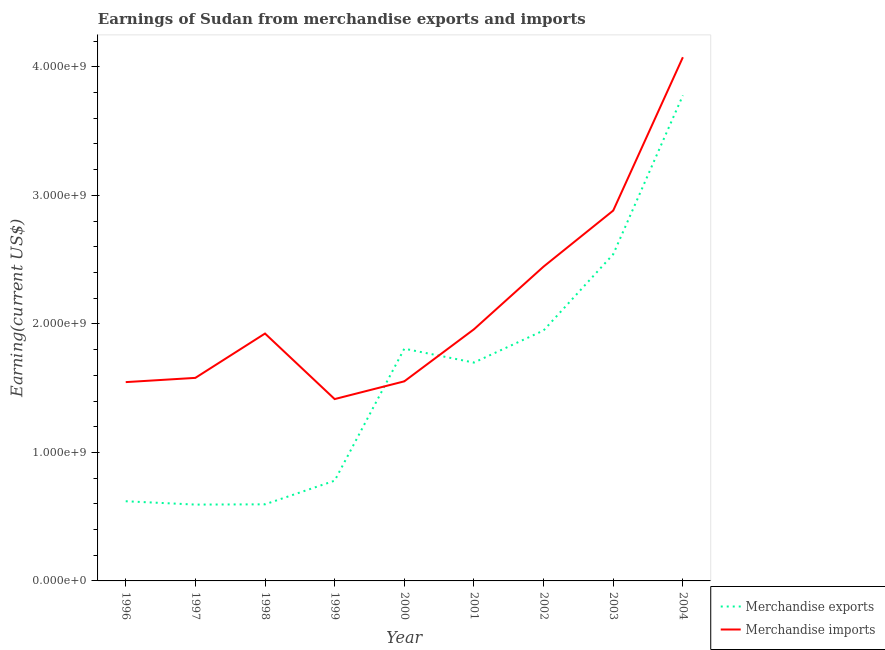How many different coloured lines are there?
Your answer should be compact. 2. Is the number of lines equal to the number of legend labels?
Give a very brief answer. Yes. What is the earnings from merchandise exports in 1998?
Keep it short and to the point. 5.96e+08. Across all years, what is the maximum earnings from merchandise exports?
Provide a succinct answer. 3.78e+09. Across all years, what is the minimum earnings from merchandise imports?
Your response must be concise. 1.42e+09. In which year was the earnings from merchandise imports maximum?
Offer a very short reply. 2004. In which year was the earnings from merchandise imports minimum?
Ensure brevity in your answer.  1999. What is the total earnings from merchandise imports in the graph?
Provide a short and direct response. 1.94e+1. What is the difference between the earnings from merchandise imports in 1998 and that in 2002?
Provide a succinct answer. -5.21e+08. What is the difference between the earnings from merchandise imports in 2002 and the earnings from merchandise exports in 1998?
Keep it short and to the point. 1.85e+09. What is the average earnings from merchandise imports per year?
Your answer should be compact. 2.15e+09. In the year 1997, what is the difference between the earnings from merchandise imports and earnings from merchandise exports?
Provide a short and direct response. 9.86e+08. In how many years, is the earnings from merchandise exports greater than 3400000000 US$?
Make the answer very short. 1. What is the ratio of the earnings from merchandise exports in 1999 to that in 2002?
Provide a short and direct response. 0.4. Is the difference between the earnings from merchandise exports in 2001 and 2003 greater than the difference between the earnings from merchandise imports in 2001 and 2003?
Offer a terse response. Yes. What is the difference between the highest and the second highest earnings from merchandise exports?
Offer a very short reply. 1.24e+09. What is the difference between the highest and the lowest earnings from merchandise exports?
Make the answer very short. 3.18e+09. In how many years, is the earnings from merchandise imports greater than the average earnings from merchandise imports taken over all years?
Offer a terse response. 3. Is the sum of the earnings from merchandise exports in 1997 and 1999 greater than the maximum earnings from merchandise imports across all years?
Ensure brevity in your answer.  No. Does the earnings from merchandise exports monotonically increase over the years?
Your response must be concise. No. Is the earnings from merchandise exports strictly greater than the earnings from merchandise imports over the years?
Your answer should be compact. No. How many lines are there?
Make the answer very short. 2. What is the difference between two consecutive major ticks on the Y-axis?
Your answer should be very brief. 1.00e+09. Does the graph contain any zero values?
Your answer should be very brief. No. Does the graph contain grids?
Offer a very short reply. No. How many legend labels are there?
Offer a very short reply. 2. How are the legend labels stacked?
Your response must be concise. Vertical. What is the title of the graph?
Provide a short and direct response. Earnings of Sudan from merchandise exports and imports. What is the label or title of the Y-axis?
Provide a succinct answer. Earning(current US$). What is the Earning(current US$) of Merchandise exports in 1996?
Make the answer very short. 6.20e+08. What is the Earning(current US$) in Merchandise imports in 1996?
Your answer should be very brief. 1.55e+09. What is the Earning(current US$) in Merchandise exports in 1997?
Provide a short and direct response. 5.94e+08. What is the Earning(current US$) in Merchandise imports in 1997?
Your response must be concise. 1.58e+09. What is the Earning(current US$) of Merchandise exports in 1998?
Make the answer very short. 5.96e+08. What is the Earning(current US$) of Merchandise imports in 1998?
Offer a very short reply. 1.92e+09. What is the Earning(current US$) in Merchandise exports in 1999?
Your response must be concise. 7.80e+08. What is the Earning(current US$) in Merchandise imports in 1999?
Keep it short and to the point. 1.42e+09. What is the Earning(current US$) of Merchandise exports in 2000?
Offer a very short reply. 1.81e+09. What is the Earning(current US$) of Merchandise imports in 2000?
Give a very brief answer. 1.55e+09. What is the Earning(current US$) of Merchandise exports in 2001?
Make the answer very short. 1.70e+09. What is the Earning(current US$) in Merchandise imports in 2001?
Give a very brief answer. 1.96e+09. What is the Earning(current US$) in Merchandise exports in 2002?
Provide a short and direct response. 1.95e+09. What is the Earning(current US$) in Merchandise imports in 2002?
Your answer should be compact. 2.45e+09. What is the Earning(current US$) of Merchandise exports in 2003?
Provide a succinct answer. 2.54e+09. What is the Earning(current US$) of Merchandise imports in 2003?
Give a very brief answer. 2.88e+09. What is the Earning(current US$) in Merchandise exports in 2004?
Provide a short and direct response. 3.78e+09. What is the Earning(current US$) in Merchandise imports in 2004?
Ensure brevity in your answer.  4.08e+09. Across all years, what is the maximum Earning(current US$) in Merchandise exports?
Ensure brevity in your answer.  3.78e+09. Across all years, what is the maximum Earning(current US$) in Merchandise imports?
Your answer should be very brief. 4.08e+09. Across all years, what is the minimum Earning(current US$) of Merchandise exports?
Your response must be concise. 5.94e+08. Across all years, what is the minimum Earning(current US$) in Merchandise imports?
Offer a terse response. 1.42e+09. What is the total Earning(current US$) of Merchandise exports in the graph?
Provide a short and direct response. 1.44e+1. What is the total Earning(current US$) in Merchandise imports in the graph?
Give a very brief answer. 1.94e+1. What is the difference between the Earning(current US$) in Merchandise exports in 1996 and that in 1997?
Your answer should be very brief. 2.60e+07. What is the difference between the Earning(current US$) of Merchandise imports in 1996 and that in 1997?
Ensure brevity in your answer.  -3.30e+07. What is the difference between the Earning(current US$) in Merchandise exports in 1996 and that in 1998?
Provide a succinct answer. 2.40e+07. What is the difference between the Earning(current US$) in Merchandise imports in 1996 and that in 1998?
Give a very brief answer. -3.78e+08. What is the difference between the Earning(current US$) of Merchandise exports in 1996 and that in 1999?
Your answer should be compact. -1.60e+08. What is the difference between the Earning(current US$) in Merchandise imports in 1996 and that in 1999?
Ensure brevity in your answer.  1.32e+08. What is the difference between the Earning(current US$) in Merchandise exports in 1996 and that in 2000?
Keep it short and to the point. -1.19e+09. What is the difference between the Earning(current US$) in Merchandise imports in 1996 and that in 2000?
Provide a short and direct response. -6.00e+06. What is the difference between the Earning(current US$) of Merchandise exports in 1996 and that in 2001?
Your answer should be compact. -1.08e+09. What is the difference between the Earning(current US$) of Merchandise imports in 1996 and that in 2001?
Provide a succinct answer. -4.11e+08. What is the difference between the Earning(current US$) of Merchandise exports in 1996 and that in 2002?
Ensure brevity in your answer.  -1.33e+09. What is the difference between the Earning(current US$) in Merchandise imports in 1996 and that in 2002?
Your response must be concise. -8.99e+08. What is the difference between the Earning(current US$) of Merchandise exports in 1996 and that in 2003?
Your answer should be compact. -1.92e+09. What is the difference between the Earning(current US$) in Merchandise imports in 1996 and that in 2003?
Make the answer very short. -1.34e+09. What is the difference between the Earning(current US$) in Merchandise exports in 1996 and that in 2004?
Offer a terse response. -3.16e+09. What is the difference between the Earning(current US$) of Merchandise imports in 1996 and that in 2004?
Your answer should be very brief. -2.53e+09. What is the difference between the Earning(current US$) of Merchandise exports in 1997 and that in 1998?
Your answer should be very brief. -2.00e+06. What is the difference between the Earning(current US$) in Merchandise imports in 1997 and that in 1998?
Provide a short and direct response. -3.45e+08. What is the difference between the Earning(current US$) in Merchandise exports in 1997 and that in 1999?
Your answer should be compact. -1.86e+08. What is the difference between the Earning(current US$) in Merchandise imports in 1997 and that in 1999?
Keep it short and to the point. 1.65e+08. What is the difference between the Earning(current US$) of Merchandise exports in 1997 and that in 2000?
Your response must be concise. -1.21e+09. What is the difference between the Earning(current US$) of Merchandise imports in 1997 and that in 2000?
Your answer should be very brief. 2.70e+07. What is the difference between the Earning(current US$) of Merchandise exports in 1997 and that in 2001?
Keep it short and to the point. -1.10e+09. What is the difference between the Earning(current US$) in Merchandise imports in 1997 and that in 2001?
Your answer should be compact. -3.78e+08. What is the difference between the Earning(current US$) in Merchandise exports in 1997 and that in 2002?
Keep it short and to the point. -1.36e+09. What is the difference between the Earning(current US$) of Merchandise imports in 1997 and that in 2002?
Provide a short and direct response. -8.66e+08. What is the difference between the Earning(current US$) in Merchandise exports in 1997 and that in 2003?
Offer a very short reply. -1.95e+09. What is the difference between the Earning(current US$) of Merchandise imports in 1997 and that in 2003?
Provide a succinct answer. -1.30e+09. What is the difference between the Earning(current US$) of Merchandise exports in 1997 and that in 2004?
Your answer should be compact. -3.18e+09. What is the difference between the Earning(current US$) in Merchandise imports in 1997 and that in 2004?
Keep it short and to the point. -2.50e+09. What is the difference between the Earning(current US$) in Merchandise exports in 1998 and that in 1999?
Your response must be concise. -1.84e+08. What is the difference between the Earning(current US$) in Merchandise imports in 1998 and that in 1999?
Offer a very short reply. 5.10e+08. What is the difference between the Earning(current US$) of Merchandise exports in 1998 and that in 2000?
Offer a terse response. -1.21e+09. What is the difference between the Earning(current US$) of Merchandise imports in 1998 and that in 2000?
Keep it short and to the point. 3.72e+08. What is the difference between the Earning(current US$) of Merchandise exports in 1998 and that in 2001?
Your answer should be very brief. -1.10e+09. What is the difference between the Earning(current US$) in Merchandise imports in 1998 and that in 2001?
Offer a very short reply. -3.30e+07. What is the difference between the Earning(current US$) in Merchandise exports in 1998 and that in 2002?
Make the answer very short. -1.35e+09. What is the difference between the Earning(current US$) of Merchandise imports in 1998 and that in 2002?
Offer a terse response. -5.21e+08. What is the difference between the Earning(current US$) of Merchandise exports in 1998 and that in 2003?
Give a very brief answer. -1.95e+09. What is the difference between the Earning(current US$) of Merchandise imports in 1998 and that in 2003?
Provide a succinct answer. -9.57e+08. What is the difference between the Earning(current US$) in Merchandise exports in 1998 and that in 2004?
Give a very brief answer. -3.18e+09. What is the difference between the Earning(current US$) in Merchandise imports in 1998 and that in 2004?
Provide a succinct answer. -2.15e+09. What is the difference between the Earning(current US$) in Merchandise exports in 1999 and that in 2000?
Provide a short and direct response. -1.03e+09. What is the difference between the Earning(current US$) in Merchandise imports in 1999 and that in 2000?
Give a very brief answer. -1.38e+08. What is the difference between the Earning(current US$) of Merchandise exports in 1999 and that in 2001?
Give a very brief answer. -9.19e+08. What is the difference between the Earning(current US$) in Merchandise imports in 1999 and that in 2001?
Provide a succinct answer. -5.43e+08. What is the difference between the Earning(current US$) of Merchandise exports in 1999 and that in 2002?
Make the answer very short. -1.17e+09. What is the difference between the Earning(current US$) of Merchandise imports in 1999 and that in 2002?
Your answer should be compact. -1.03e+09. What is the difference between the Earning(current US$) of Merchandise exports in 1999 and that in 2003?
Give a very brief answer. -1.76e+09. What is the difference between the Earning(current US$) of Merchandise imports in 1999 and that in 2003?
Give a very brief answer. -1.47e+09. What is the difference between the Earning(current US$) in Merchandise exports in 1999 and that in 2004?
Keep it short and to the point. -3.00e+09. What is the difference between the Earning(current US$) in Merchandise imports in 1999 and that in 2004?
Your answer should be very brief. -2.66e+09. What is the difference between the Earning(current US$) in Merchandise exports in 2000 and that in 2001?
Provide a short and direct response. 1.08e+08. What is the difference between the Earning(current US$) in Merchandise imports in 2000 and that in 2001?
Give a very brief answer. -4.05e+08. What is the difference between the Earning(current US$) in Merchandise exports in 2000 and that in 2002?
Give a very brief answer. -1.42e+08. What is the difference between the Earning(current US$) of Merchandise imports in 2000 and that in 2002?
Keep it short and to the point. -8.93e+08. What is the difference between the Earning(current US$) of Merchandise exports in 2000 and that in 2003?
Offer a very short reply. -7.35e+08. What is the difference between the Earning(current US$) in Merchandise imports in 2000 and that in 2003?
Your answer should be compact. -1.33e+09. What is the difference between the Earning(current US$) in Merchandise exports in 2000 and that in 2004?
Offer a very short reply. -1.97e+09. What is the difference between the Earning(current US$) in Merchandise imports in 2000 and that in 2004?
Keep it short and to the point. -2.52e+09. What is the difference between the Earning(current US$) of Merchandise exports in 2001 and that in 2002?
Provide a short and direct response. -2.50e+08. What is the difference between the Earning(current US$) of Merchandise imports in 2001 and that in 2002?
Your answer should be compact. -4.88e+08. What is the difference between the Earning(current US$) of Merchandise exports in 2001 and that in 2003?
Provide a short and direct response. -8.43e+08. What is the difference between the Earning(current US$) in Merchandise imports in 2001 and that in 2003?
Provide a succinct answer. -9.24e+08. What is the difference between the Earning(current US$) in Merchandise exports in 2001 and that in 2004?
Offer a very short reply. -2.08e+09. What is the difference between the Earning(current US$) in Merchandise imports in 2001 and that in 2004?
Your answer should be compact. -2.12e+09. What is the difference between the Earning(current US$) of Merchandise exports in 2002 and that in 2003?
Your answer should be very brief. -5.93e+08. What is the difference between the Earning(current US$) of Merchandise imports in 2002 and that in 2003?
Provide a short and direct response. -4.36e+08. What is the difference between the Earning(current US$) in Merchandise exports in 2002 and that in 2004?
Provide a short and direct response. -1.83e+09. What is the difference between the Earning(current US$) in Merchandise imports in 2002 and that in 2004?
Provide a succinct answer. -1.63e+09. What is the difference between the Earning(current US$) in Merchandise exports in 2003 and that in 2004?
Keep it short and to the point. -1.24e+09. What is the difference between the Earning(current US$) of Merchandise imports in 2003 and that in 2004?
Give a very brief answer. -1.19e+09. What is the difference between the Earning(current US$) of Merchandise exports in 1996 and the Earning(current US$) of Merchandise imports in 1997?
Provide a succinct answer. -9.60e+08. What is the difference between the Earning(current US$) of Merchandise exports in 1996 and the Earning(current US$) of Merchandise imports in 1998?
Ensure brevity in your answer.  -1.30e+09. What is the difference between the Earning(current US$) in Merchandise exports in 1996 and the Earning(current US$) in Merchandise imports in 1999?
Provide a succinct answer. -7.95e+08. What is the difference between the Earning(current US$) in Merchandise exports in 1996 and the Earning(current US$) in Merchandise imports in 2000?
Keep it short and to the point. -9.33e+08. What is the difference between the Earning(current US$) of Merchandise exports in 1996 and the Earning(current US$) of Merchandise imports in 2001?
Your response must be concise. -1.34e+09. What is the difference between the Earning(current US$) of Merchandise exports in 1996 and the Earning(current US$) of Merchandise imports in 2002?
Your answer should be compact. -1.83e+09. What is the difference between the Earning(current US$) in Merchandise exports in 1996 and the Earning(current US$) in Merchandise imports in 2003?
Provide a succinct answer. -2.26e+09. What is the difference between the Earning(current US$) in Merchandise exports in 1996 and the Earning(current US$) in Merchandise imports in 2004?
Offer a terse response. -3.46e+09. What is the difference between the Earning(current US$) of Merchandise exports in 1997 and the Earning(current US$) of Merchandise imports in 1998?
Your response must be concise. -1.33e+09. What is the difference between the Earning(current US$) of Merchandise exports in 1997 and the Earning(current US$) of Merchandise imports in 1999?
Offer a very short reply. -8.21e+08. What is the difference between the Earning(current US$) in Merchandise exports in 1997 and the Earning(current US$) in Merchandise imports in 2000?
Your answer should be very brief. -9.59e+08. What is the difference between the Earning(current US$) of Merchandise exports in 1997 and the Earning(current US$) of Merchandise imports in 2001?
Provide a short and direct response. -1.36e+09. What is the difference between the Earning(current US$) in Merchandise exports in 1997 and the Earning(current US$) in Merchandise imports in 2002?
Keep it short and to the point. -1.85e+09. What is the difference between the Earning(current US$) in Merchandise exports in 1997 and the Earning(current US$) in Merchandise imports in 2003?
Keep it short and to the point. -2.29e+09. What is the difference between the Earning(current US$) in Merchandise exports in 1997 and the Earning(current US$) in Merchandise imports in 2004?
Your response must be concise. -3.48e+09. What is the difference between the Earning(current US$) of Merchandise exports in 1998 and the Earning(current US$) of Merchandise imports in 1999?
Ensure brevity in your answer.  -8.19e+08. What is the difference between the Earning(current US$) of Merchandise exports in 1998 and the Earning(current US$) of Merchandise imports in 2000?
Ensure brevity in your answer.  -9.57e+08. What is the difference between the Earning(current US$) in Merchandise exports in 1998 and the Earning(current US$) in Merchandise imports in 2001?
Offer a very short reply. -1.36e+09. What is the difference between the Earning(current US$) in Merchandise exports in 1998 and the Earning(current US$) in Merchandise imports in 2002?
Offer a very short reply. -1.85e+09. What is the difference between the Earning(current US$) in Merchandise exports in 1998 and the Earning(current US$) in Merchandise imports in 2003?
Keep it short and to the point. -2.29e+09. What is the difference between the Earning(current US$) of Merchandise exports in 1998 and the Earning(current US$) of Merchandise imports in 2004?
Keep it short and to the point. -3.48e+09. What is the difference between the Earning(current US$) in Merchandise exports in 1999 and the Earning(current US$) in Merchandise imports in 2000?
Offer a terse response. -7.73e+08. What is the difference between the Earning(current US$) of Merchandise exports in 1999 and the Earning(current US$) of Merchandise imports in 2001?
Provide a short and direct response. -1.18e+09. What is the difference between the Earning(current US$) in Merchandise exports in 1999 and the Earning(current US$) in Merchandise imports in 2002?
Your response must be concise. -1.67e+09. What is the difference between the Earning(current US$) of Merchandise exports in 1999 and the Earning(current US$) of Merchandise imports in 2003?
Give a very brief answer. -2.10e+09. What is the difference between the Earning(current US$) in Merchandise exports in 1999 and the Earning(current US$) in Merchandise imports in 2004?
Ensure brevity in your answer.  -3.30e+09. What is the difference between the Earning(current US$) of Merchandise exports in 2000 and the Earning(current US$) of Merchandise imports in 2001?
Keep it short and to the point. -1.51e+08. What is the difference between the Earning(current US$) of Merchandise exports in 2000 and the Earning(current US$) of Merchandise imports in 2002?
Offer a terse response. -6.39e+08. What is the difference between the Earning(current US$) in Merchandise exports in 2000 and the Earning(current US$) in Merchandise imports in 2003?
Make the answer very short. -1.08e+09. What is the difference between the Earning(current US$) of Merchandise exports in 2000 and the Earning(current US$) of Merchandise imports in 2004?
Offer a very short reply. -2.27e+09. What is the difference between the Earning(current US$) of Merchandise exports in 2001 and the Earning(current US$) of Merchandise imports in 2002?
Offer a terse response. -7.47e+08. What is the difference between the Earning(current US$) of Merchandise exports in 2001 and the Earning(current US$) of Merchandise imports in 2003?
Offer a terse response. -1.18e+09. What is the difference between the Earning(current US$) in Merchandise exports in 2001 and the Earning(current US$) in Merchandise imports in 2004?
Your answer should be compact. -2.38e+09. What is the difference between the Earning(current US$) in Merchandise exports in 2002 and the Earning(current US$) in Merchandise imports in 2003?
Offer a terse response. -9.33e+08. What is the difference between the Earning(current US$) in Merchandise exports in 2002 and the Earning(current US$) in Merchandise imports in 2004?
Provide a succinct answer. -2.13e+09. What is the difference between the Earning(current US$) in Merchandise exports in 2003 and the Earning(current US$) in Merchandise imports in 2004?
Your answer should be very brief. -1.53e+09. What is the average Earning(current US$) in Merchandise exports per year?
Ensure brevity in your answer.  1.60e+09. What is the average Earning(current US$) of Merchandise imports per year?
Offer a terse response. 2.15e+09. In the year 1996, what is the difference between the Earning(current US$) in Merchandise exports and Earning(current US$) in Merchandise imports?
Provide a short and direct response. -9.27e+08. In the year 1997, what is the difference between the Earning(current US$) in Merchandise exports and Earning(current US$) in Merchandise imports?
Your response must be concise. -9.86e+08. In the year 1998, what is the difference between the Earning(current US$) in Merchandise exports and Earning(current US$) in Merchandise imports?
Your response must be concise. -1.33e+09. In the year 1999, what is the difference between the Earning(current US$) in Merchandise exports and Earning(current US$) in Merchandise imports?
Give a very brief answer. -6.35e+08. In the year 2000, what is the difference between the Earning(current US$) in Merchandise exports and Earning(current US$) in Merchandise imports?
Your response must be concise. 2.54e+08. In the year 2001, what is the difference between the Earning(current US$) in Merchandise exports and Earning(current US$) in Merchandise imports?
Provide a short and direct response. -2.59e+08. In the year 2002, what is the difference between the Earning(current US$) in Merchandise exports and Earning(current US$) in Merchandise imports?
Make the answer very short. -4.97e+08. In the year 2003, what is the difference between the Earning(current US$) of Merchandise exports and Earning(current US$) of Merchandise imports?
Provide a succinct answer. -3.40e+08. In the year 2004, what is the difference between the Earning(current US$) in Merchandise exports and Earning(current US$) in Merchandise imports?
Provide a succinct answer. -2.97e+08. What is the ratio of the Earning(current US$) of Merchandise exports in 1996 to that in 1997?
Provide a succinct answer. 1.04. What is the ratio of the Earning(current US$) in Merchandise imports in 1996 to that in 1997?
Offer a terse response. 0.98. What is the ratio of the Earning(current US$) of Merchandise exports in 1996 to that in 1998?
Give a very brief answer. 1.04. What is the ratio of the Earning(current US$) of Merchandise imports in 1996 to that in 1998?
Your answer should be compact. 0.8. What is the ratio of the Earning(current US$) of Merchandise exports in 1996 to that in 1999?
Offer a very short reply. 0.79. What is the ratio of the Earning(current US$) in Merchandise imports in 1996 to that in 1999?
Your answer should be compact. 1.09. What is the ratio of the Earning(current US$) in Merchandise exports in 1996 to that in 2000?
Your answer should be very brief. 0.34. What is the ratio of the Earning(current US$) in Merchandise exports in 1996 to that in 2001?
Give a very brief answer. 0.36. What is the ratio of the Earning(current US$) of Merchandise imports in 1996 to that in 2001?
Keep it short and to the point. 0.79. What is the ratio of the Earning(current US$) of Merchandise exports in 1996 to that in 2002?
Provide a short and direct response. 0.32. What is the ratio of the Earning(current US$) of Merchandise imports in 1996 to that in 2002?
Offer a terse response. 0.63. What is the ratio of the Earning(current US$) in Merchandise exports in 1996 to that in 2003?
Offer a very short reply. 0.24. What is the ratio of the Earning(current US$) of Merchandise imports in 1996 to that in 2003?
Ensure brevity in your answer.  0.54. What is the ratio of the Earning(current US$) in Merchandise exports in 1996 to that in 2004?
Offer a very short reply. 0.16. What is the ratio of the Earning(current US$) in Merchandise imports in 1996 to that in 2004?
Ensure brevity in your answer.  0.38. What is the ratio of the Earning(current US$) in Merchandise exports in 1997 to that in 1998?
Ensure brevity in your answer.  1. What is the ratio of the Earning(current US$) of Merchandise imports in 1997 to that in 1998?
Your answer should be compact. 0.82. What is the ratio of the Earning(current US$) of Merchandise exports in 1997 to that in 1999?
Provide a succinct answer. 0.76. What is the ratio of the Earning(current US$) of Merchandise imports in 1997 to that in 1999?
Offer a very short reply. 1.12. What is the ratio of the Earning(current US$) of Merchandise exports in 1997 to that in 2000?
Ensure brevity in your answer.  0.33. What is the ratio of the Earning(current US$) in Merchandise imports in 1997 to that in 2000?
Provide a succinct answer. 1.02. What is the ratio of the Earning(current US$) in Merchandise exports in 1997 to that in 2001?
Give a very brief answer. 0.35. What is the ratio of the Earning(current US$) in Merchandise imports in 1997 to that in 2001?
Provide a short and direct response. 0.81. What is the ratio of the Earning(current US$) of Merchandise exports in 1997 to that in 2002?
Keep it short and to the point. 0.3. What is the ratio of the Earning(current US$) of Merchandise imports in 1997 to that in 2002?
Your response must be concise. 0.65. What is the ratio of the Earning(current US$) of Merchandise exports in 1997 to that in 2003?
Provide a succinct answer. 0.23. What is the ratio of the Earning(current US$) of Merchandise imports in 1997 to that in 2003?
Provide a succinct answer. 0.55. What is the ratio of the Earning(current US$) in Merchandise exports in 1997 to that in 2004?
Offer a very short reply. 0.16. What is the ratio of the Earning(current US$) in Merchandise imports in 1997 to that in 2004?
Keep it short and to the point. 0.39. What is the ratio of the Earning(current US$) of Merchandise exports in 1998 to that in 1999?
Offer a terse response. 0.76. What is the ratio of the Earning(current US$) of Merchandise imports in 1998 to that in 1999?
Offer a terse response. 1.36. What is the ratio of the Earning(current US$) of Merchandise exports in 1998 to that in 2000?
Offer a very short reply. 0.33. What is the ratio of the Earning(current US$) of Merchandise imports in 1998 to that in 2000?
Make the answer very short. 1.24. What is the ratio of the Earning(current US$) in Merchandise exports in 1998 to that in 2001?
Provide a short and direct response. 0.35. What is the ratio of the Earning(current US$) in Merchandise imports in 1998 to that in 2001?
Provide a succinct answer. 0.98. What is the ratio of the Earning(current US$) in Merchandise exports in 1998 to that in 2002?
Provide a succinct answer. 0.31. What is the ratio of the Earning(current US$) of Merchandise imports in 1998 to that in 2002?
Offer a very short reply. 0.79. What is the ratio of the Earning(current US$) of Merchandise exports in 1998 to that in 2003?
Make the answer very short. 0.23. What is the ratio of the Earning(current US$) in Merchandise imports in 1998 to that in 2003?
Provide a short and direct response. 0.67. What is the ratio of the Earning(current US$) of Merchandise exports in 1998 to that in 2004?
Your answer should be compact. 0.16. What is the ratio of the Earning(current US$) in Merchandise imports in 1998 to that in 2004?
Ensure brevity in your answer.  0.47. What is the ratio of the Earning(current US$) in Merchandise exports in 1999 to that in 2000?
Make the answer very short. 0.43. What is the ratio of the Earning(current US$) of Merchandise imports in 1999 to that in 2000?
Provide a short and direct response. 0.91. What is the ratio of the Earning(current US$) of Merchandise exports in 1999 to that in 2001?
Make the answer very short. 0.46. What is the ratio of the Earning(current US$) of Merchandise imports in 1999 to that in 2001?
Provide a succinct answer. 0.72. What is the ratio of the Earning(current US$) in Merchandise exports in 1999 to that in 2002?
Ensure brevity in your answer.  0.4. What is the ratio of the Earning(current US$) in Merchandise imports in 1999 to that in 2002?
Give a very brief answer. 0.58. What is the ratio of the Earning(current US$) in Merchandise exports in 1999 to that in 2003?
Ensure brevity in your answer.  0.31. What is the ratio of the Earning(current US$) in Merchandise imports in 1999 to that in 2003?
Your response must be concise. 0.49. What is the ratio of the Earning(current US$) of Merchandise exports in 1999 to that in 2004?
Give a very brief answer. 0.21. What is the ratio of the Earning(current US$) in Merchandise imports in 1999 to that in 2004?
Give a very brief answer. 0.35. What is the ratio of the Earning(current US$) in Merchandise exports in 2000 to that in 2001?
Your response must be concise. 1.06. What is the ratio of the Earning(current US$) of Merchandise imports in 2000 to that in 2001?
Your response must be concise. 0.79. What is the ratio of the Earning(current US$) of Merchandise exports in 2000 to that in 2002?
Offer a very short reply. 0.93. What is the ratio of the Earning(current US$) of Merchandise imports in 2000 to that in 2002?
Keep it short and to the point. 0.63. What is the ratio of the Earning(current US$) in Merchandise exports in 2000 to that in 2003?
Ensure brevity in your answer.  0.71. What is the ratio of the Earning(current US$) of Merchandise imports in 2000 to that in 2003?
Ensure brevity in your answer.  0.54. What is the ratio of the Earning(current US$) of Merchandise exports in 2000 to that in 2004?
Your response must be concise. 0.48. What is the ratio of the Earning(current US$) in Merchandise imports in 2000 to that in 2004?
Give a very brief answer. 0.38. What is the ratio of the Earning(current US$) of Merchandise exports in 2001 to that in 2002?
Your answer should be compact. 0.87. What is the ratio of the Earning(current US$) of Merchandise imports in 2001 to that in 2002?
Ensure brevity in your answer.  0.8. What is the ratio of the Earning(current US$) of Merchandise exports in 2001 to that in 2003?
Ensure brevity in your answer.  0.67. What is the ratio of the Earning(current US$) of Merchandise imports in 2001 to that in 2003?
Your response must be concise. 0.68. What is the ratio of the Earning(current US$) of Merchandise exports in 2001 to that in 2004?
Provide a succinct answer. 0.45. What is the ratio of the Earning(current US$) of Merchandise imports in 2001 to that in 2004?
Your answer should be very brief. 0.48. What is the ratio of the Earning(current US$) in Merchandise exports in 2002 to that in 2003?
Your response must be concise. 0.77. What is the ratio of the Earning(current US$) in Merchandise imports in 2002 to that in 2003?
Offer a terse response. 0.85. What is the ratio of the Earning(current US$) of Merchandise exports in 2002 to that in 2004?
Ensure brevity in your answer.  0.52. What is the ratio of the Earning(current US$) of Merchandise imports in 2002 to that in 2004?
Your answer should be very brief. 0.6. What is the ratio of the Earning(current US$) in Merchandise exports in 2003 to that in 2004?
Provide a succinct answer. 0.67. What is the ratio of the Earning(current US$) in Merchandise imports in 2003 to that in 2004?
Provide a short and direct response. 0.71. What is the difference between the highest and the second highest Earning(current US$) of Merchandise exports?
Your answer should be very brief. 1.24e+09. What is the difference between the highest and the second highest Earning(current US$) of Merchandise imports?
Provide a succinct answer. 1.19e+09. What is the difference between the highest and the lowest Earning(current US$) in Merchandise exports?
Ensure brevity in your answer.  3.18e+09. What is the difference between the highest and the lowest Earning(current US$) in Merchandise imports?
Your answer should be very brief. 2.66e+09. 